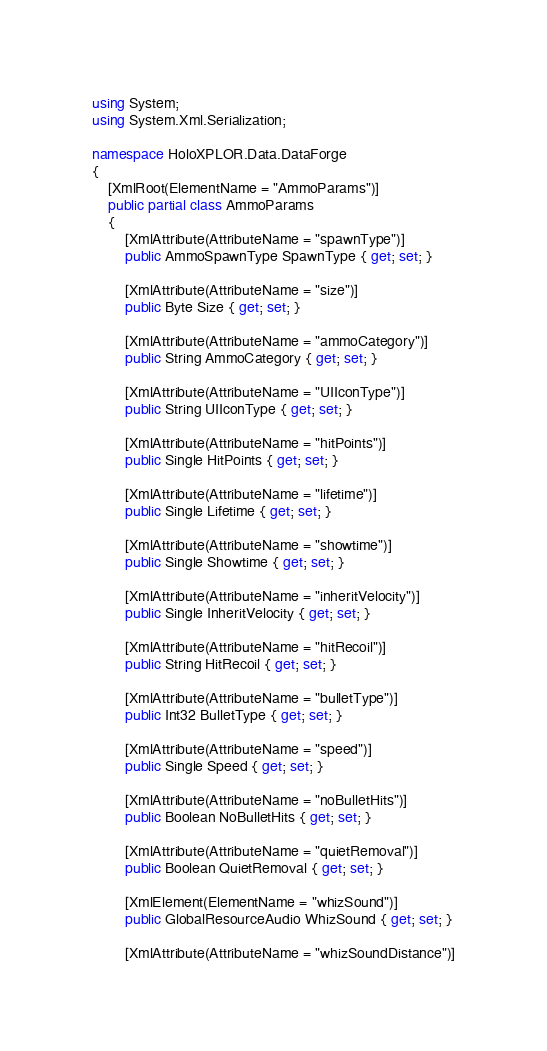Convert code to text. <code><loc_0><loc_0><loc_500><loc_500><_C#_>using System;
using System.Xml.Serialization;

namespace HoloXPLOR.Data.DataForge
{
    [XmlRoot(ElementName = "AmmoParams")]
    public partial class AmmoParams
    {
        [XmlAttribute(AttributeName = "spawnType")]
        public AmmoSpawnType SpawnType { get; set; }

        [XmlAttribute(AttributeName = "size")]
        public Byte Size { get; set; }

        [XmlAttribute(AttributeName = "ammoCategory")]
        public String AmmoCategory { get; set; }

        [XmlAttribute(AttributeName = "UIIconType")]
        public String UIIconType { get; set; }

        [XmlAttribute(AttributeName = "hitPoints")]
        public Single HitPoints { get; set; }

        [XmlAttribute(AttributeName = "lifetime")]
        public Single Lifetime { get; set; }

        [XmlAttribute(AttributeName = "showtime")]
        public Single Showtime { get; set; }

        [XmlAttribute(AttributeName = "inheritVelocity")]
        public Single InheritVelocity { get; set; }

        [XmlAttribute(AttributeName = "hitRecoil")]
        public String HitRecoil { get; set; }

        [XmlAttribute(AttributeName = "bulletType")]
        public Int32 BulletType { get; set; }

        [XmlAttribute(AttributeName = "speed")]
        public Single Speed { get; set; }

        [XmlAttribute(AttributeName = "noBulletHits")]
        public Boolean NoBulletHits { get; set; }

        [XmlAttribute(AttributeName = "quietRemoval")]
        public Boolean QuietRemoval { get; set; }

        [XmlElement(ElementName = "whizSound")]
        public GlobalResourceAudio WhizSound { get; set; }

        [XmlAttribute(AttributeName = "whizSoundDistance")]</code> 